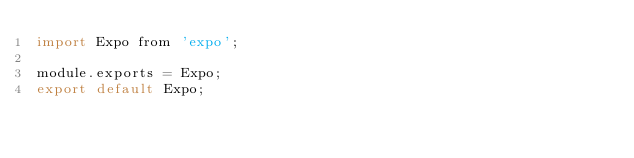Convert code to text. <code><loc_0><loc_0><loc_500><loc_500><_JavaScript_>import Expo from 'expo';

module.exports = Expo;
export default Expo;
</code> 